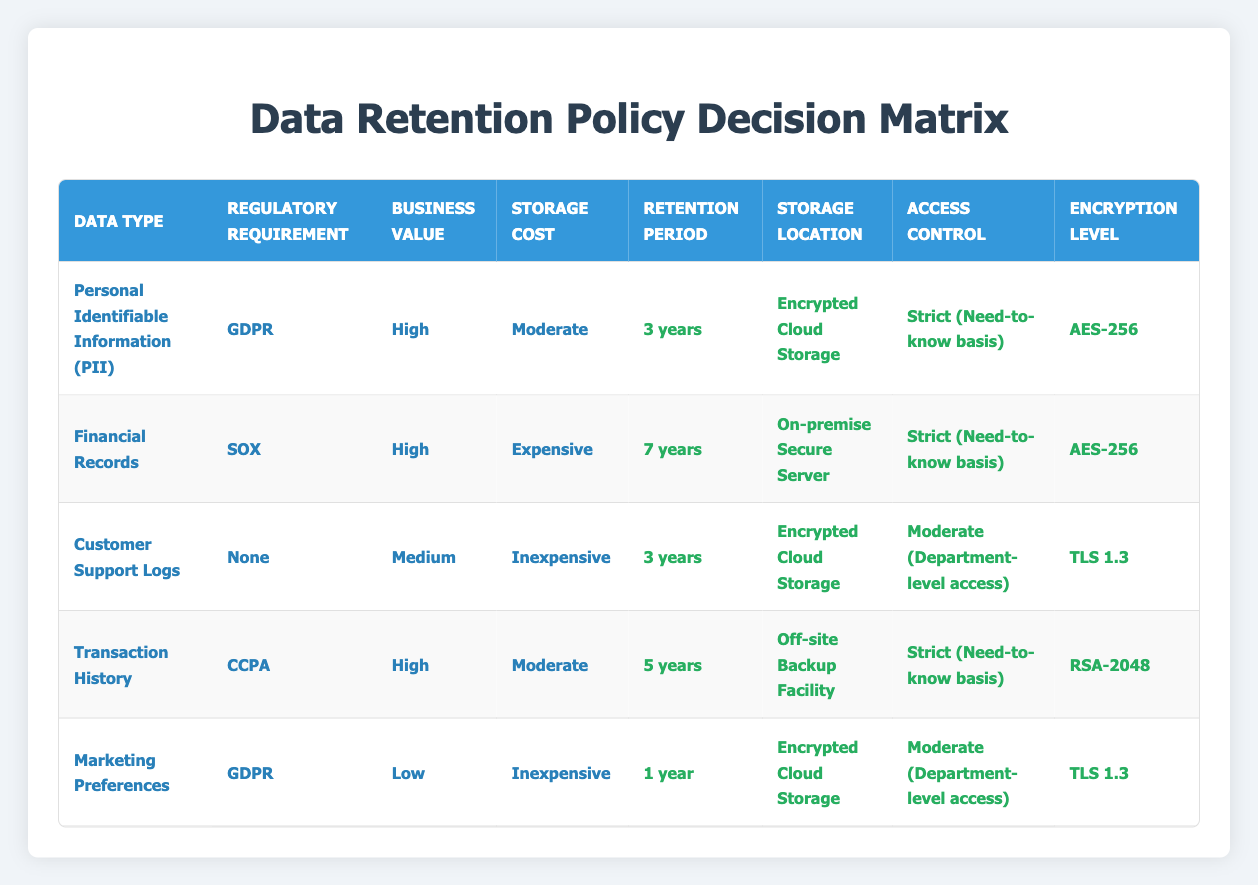What is the retention period for Personal Identifiable Information (PII)? The table indicates that for Personal Identifiable Information (PII) under GDPR, the retention period is specified as 3 years.
Answer: 3 years How many data types have a high business value? Examining the table, there are four data types categorized with a high business value: Personal Identifiable Information (PII), Financial Records, Transaction History, and Marketing Preferences. Thus, the total count is four.
Answer: 4 Is the storage location for Customer Support Logs encrypted? The table states that Customer Support Logs are stored in "Encrypted Cloud Storage," which confirms that the storage location is indeed encrypted.
Answer: Yes What is the minimum retention period for data types that require GDPR compliance? The table shows two data types requiring GDPR compliance: Personal Identifiable Information (PII) has a retention period of 3 years, and Marketing Preferences has a retention period of 1 year. Therefore, the minimum retention period is 1 year.
Answer: 1 year What is the relationship between storage cost and retention period for Financial Records? For Financial Records, the storage cost is classified as expensive, and the retention period is stated to be 7 years. This indicates that higher storage costs are associated with the longer retention period required by regulatory standards (SOX).
Answer: The storage cost is expensive and the retention period is 7 years How many types of data have a retention period of 3 years? The table shows that Customer Support Logs and Personal Identifiable Information (PII) both have a retention period of 3 years. This means there are two data types with this retention period.
Answer: 2 Is there any data type stored in cold storage? The table does not list any data types with cold storage as the storage location. Therefore, the answer is no.
Answer: No What is the average storage cost for data types with high business value? The data types with high business value include Personal Identifiable Information (PII) with moderate storage cost, Financial Records with expensive storage cost, and Transaction History with moderate storage cost. Calculating the average results in (1 moderate + 1 expensive + 1 moderate) / 3 = 1.33, indicating a storage cost of about 'Moderate' on average.
Answer: Moderate What is the encryption level for Transaction History? According to the table, the encryption level specified for Transaction History is RSA-2048.
Answer: RSA-2048 